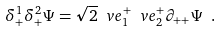Convert formula to latex. <formula><loc_0><loc_0><loc_500><loc_500>\delta _ { + } ^ { 1 } \delta _ { + } ^ { 2 } \Psi = \sqrt { 2 } \ v e _ { 1 } ^ { + } \ v e _ { 2 } ^ { + } \partial _ { + + } \Psi \ .</formula> 